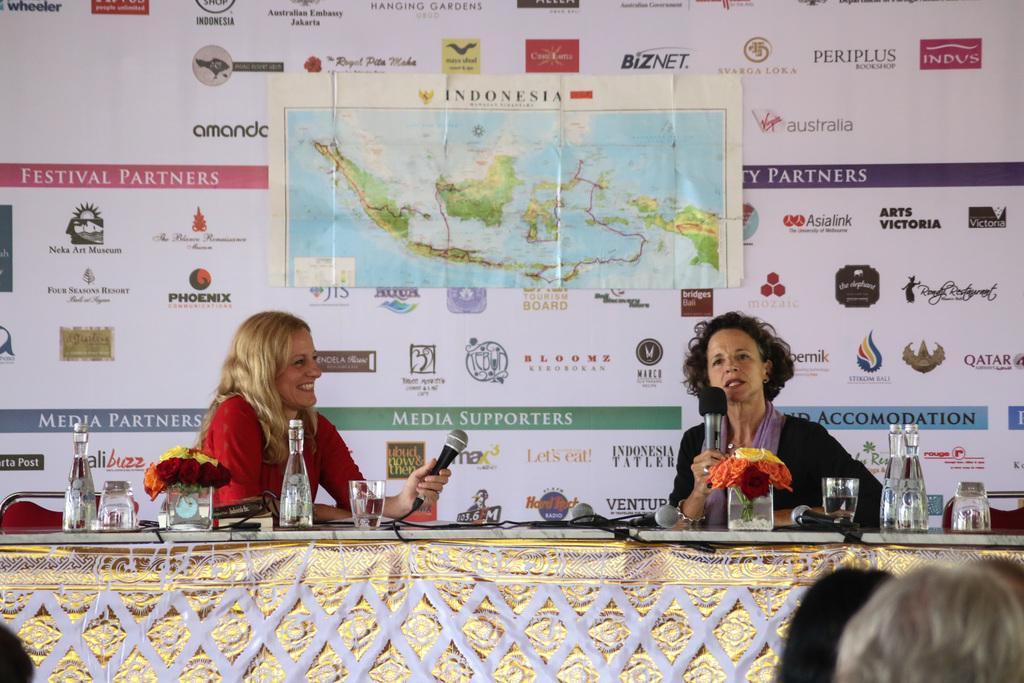Could you give a brief overview of what you see in this image? As we can see in the image there are few people, banners, two persons holding mics and there is a table. On table there are glasses, flowers and bottles. 